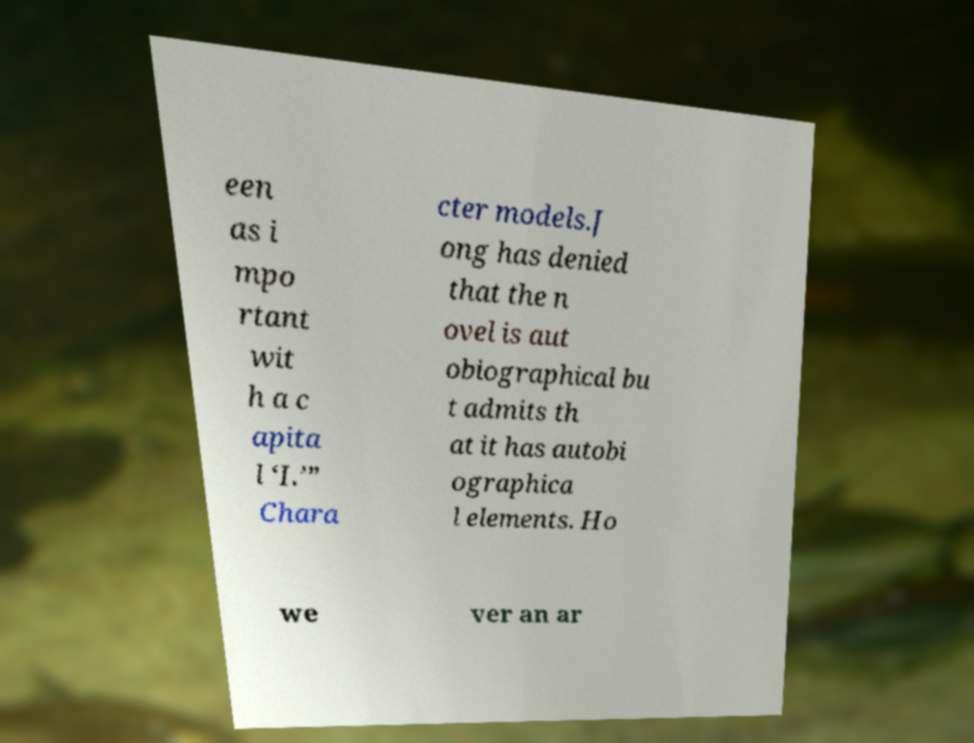What messages or text are displayed in this image? I need them in a readable, typed format. een as i mpo rtant wit h a c apita l ‘I.’” Chara cter models.J ong has denied that the n ovel is aut obiographical bu t admits th at it has autobi ographica l elements. Ho we ver an ar 